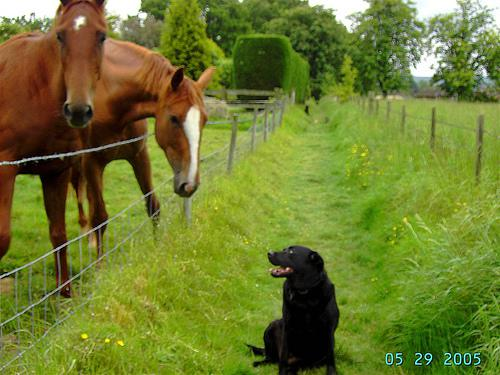Question: where is the dog sitting?
Choices:
A. On the ground.
B. In the truck.
C. On the porch.
D. In the backseat.
Answer with the letter. Answer: A Question: what is the color of the grass?
Choices:
A. Blue.
B. Brown.
C. Orange.
D. Green.
Answer with the letter. Answer: D Question: why is the horse leaning over the fence?
Choices:
A. To get to the grass.
B. To get an apple.
C. To look at the dog.
D. To see the neighbor.
Answer with the letter. Answer: C Question: how is the dog placed in the photo?
Choices:
A. At the top.
B. At the right.
C. To the left.
D. In the middle.
Answer with the letter. Answer: D Question: when is this photo taken?
Choices:
A. 02 23 2010.
B. 07 15 1995.
C. 05 02 1980.
D. 05 29 2005.
Answer with the letter. Answer: D 